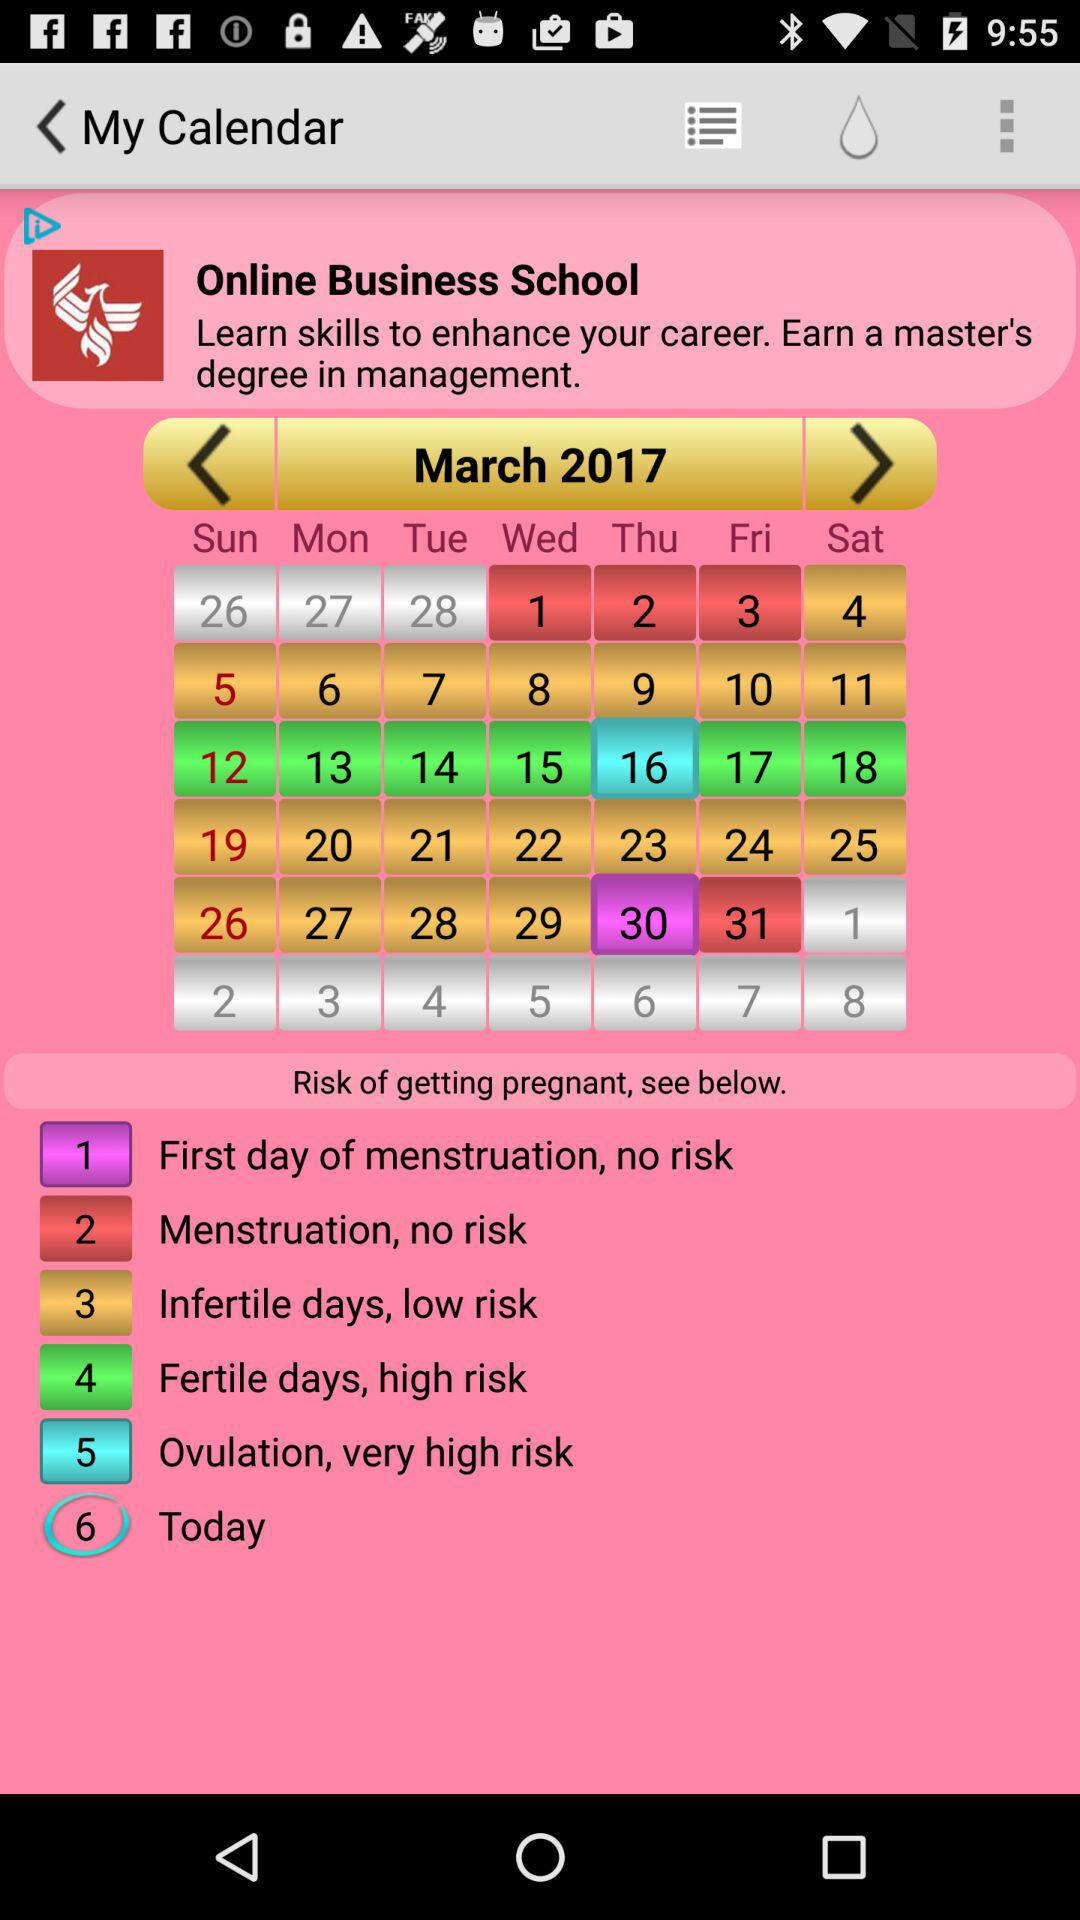Which month is shown? The shown month is March. 